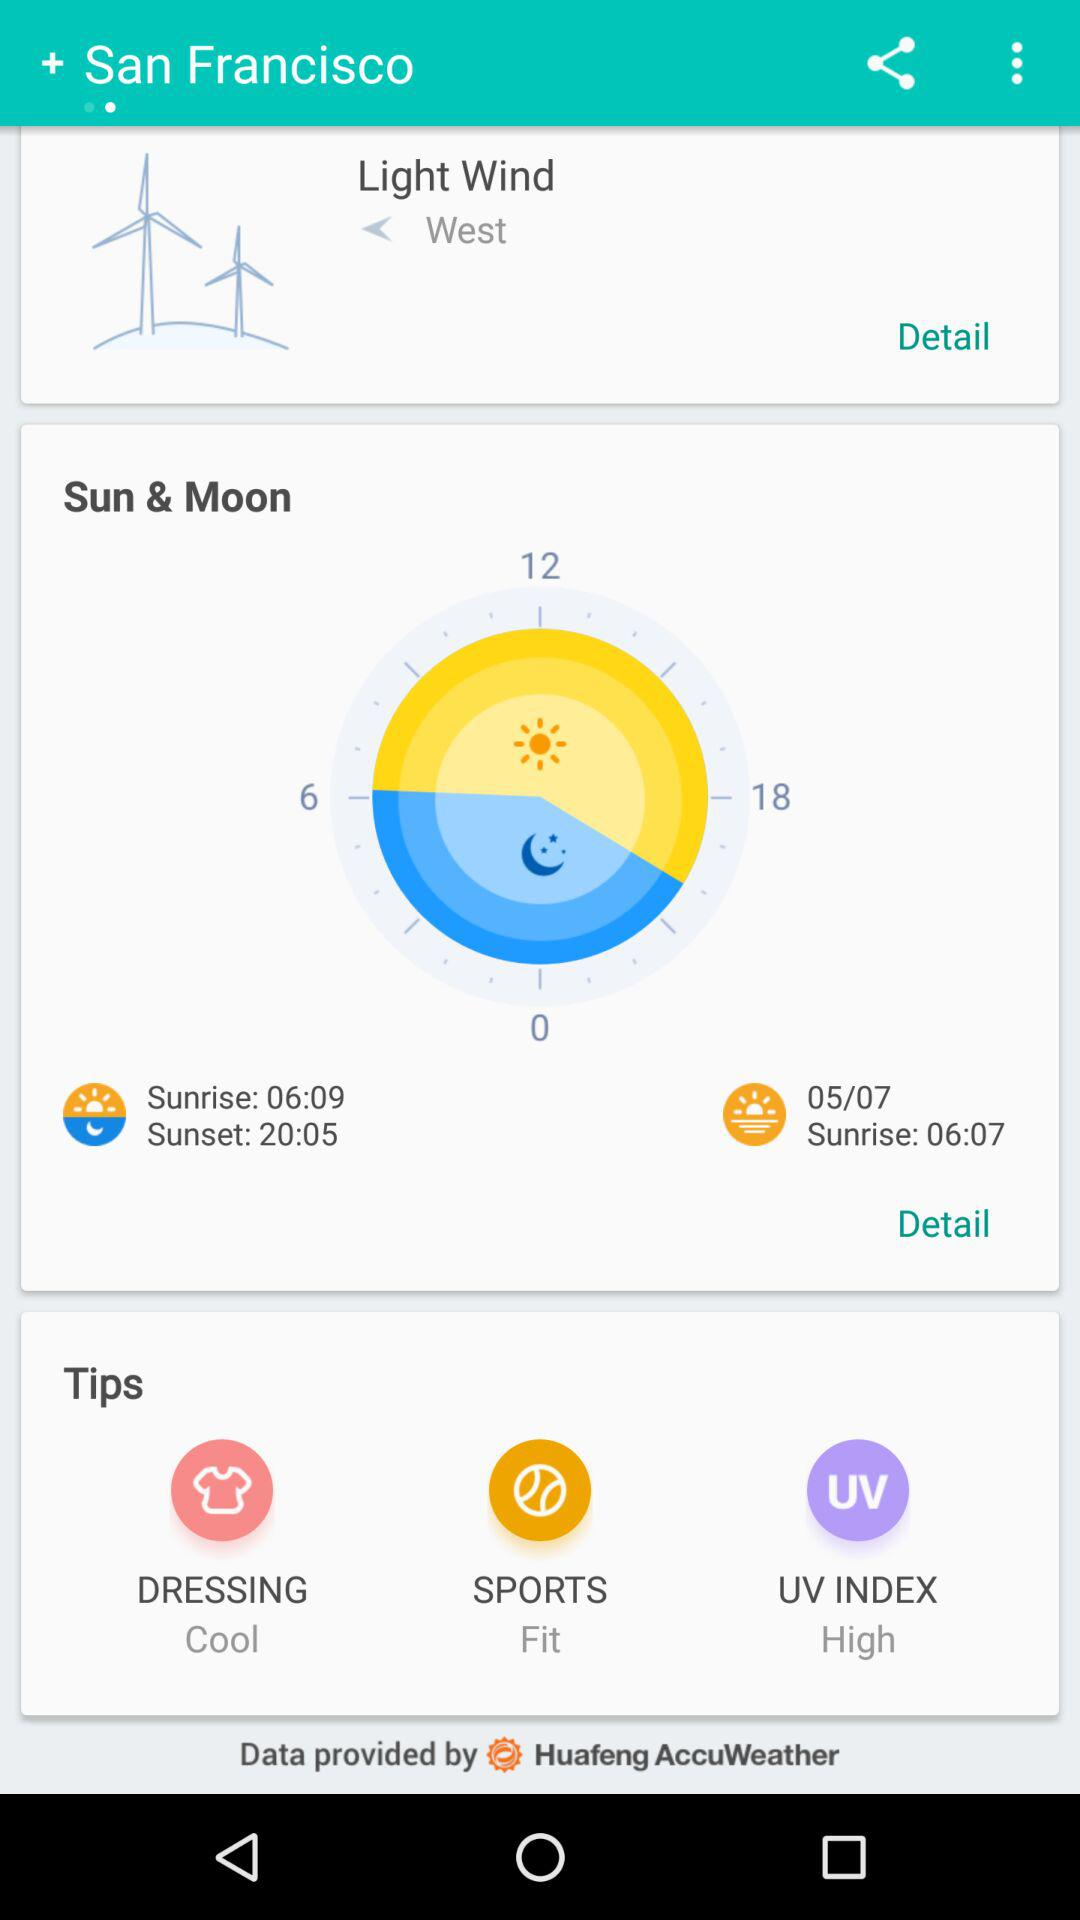What is the UV index?
Answer the question using a single word or phrase. High 